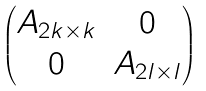Convert formula to latex. <formula><loc_0><loc_0><loc_500><loc_500>\begin{pmatrix} A _ { 2 k \times k } & 0 \\ 0 & A _ { 2 l \times l } \end{pmatrix}</formula> 